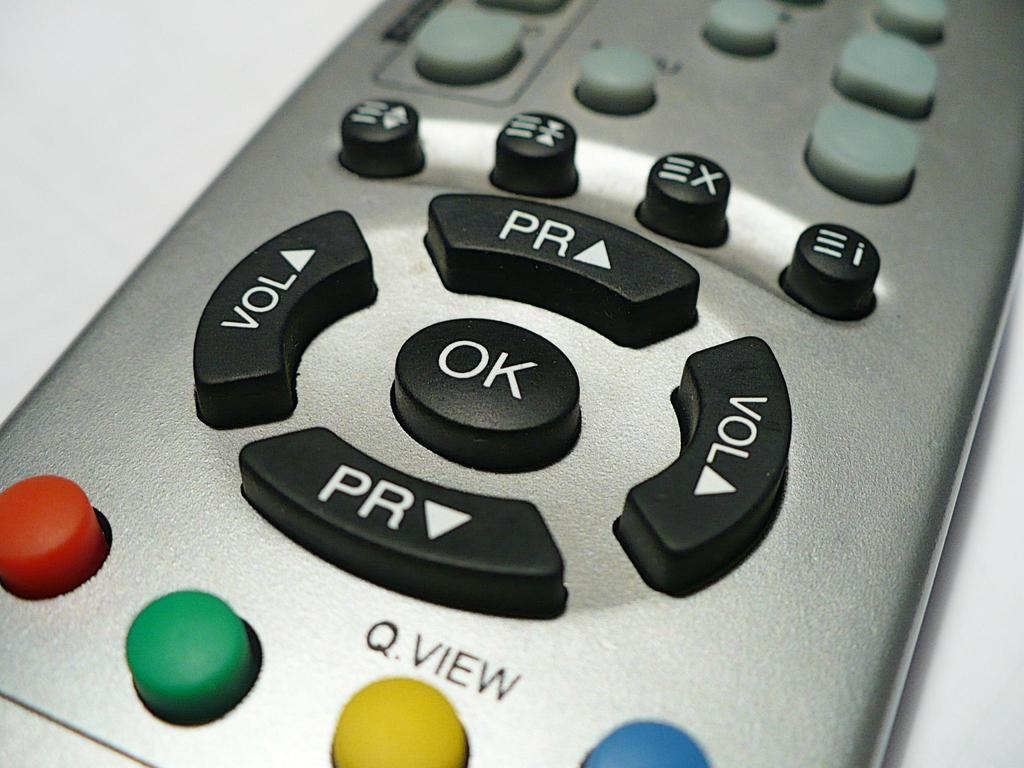<image>
Give a short and clear explanation of the subsequent image. The volume button can be found to the right and left of the OK button. 